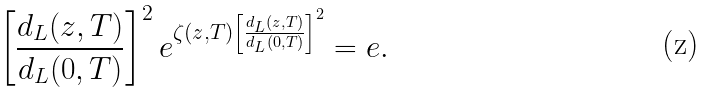Convert formula to latex. <formula><loc_0><loc_0><loc_500><loc_500>\left [ \frac { d _ { L } ( z , T ) } { d _ { L } ( 0 , T ) } \right ] ^ { 2 } e ^ { \zeta ( z , T ) \left [ \frac { d _ { L } ( z , T ) } { d _ { L } ( 0 , T ) } \right ] ^ { 2 } } = e .</formula> 